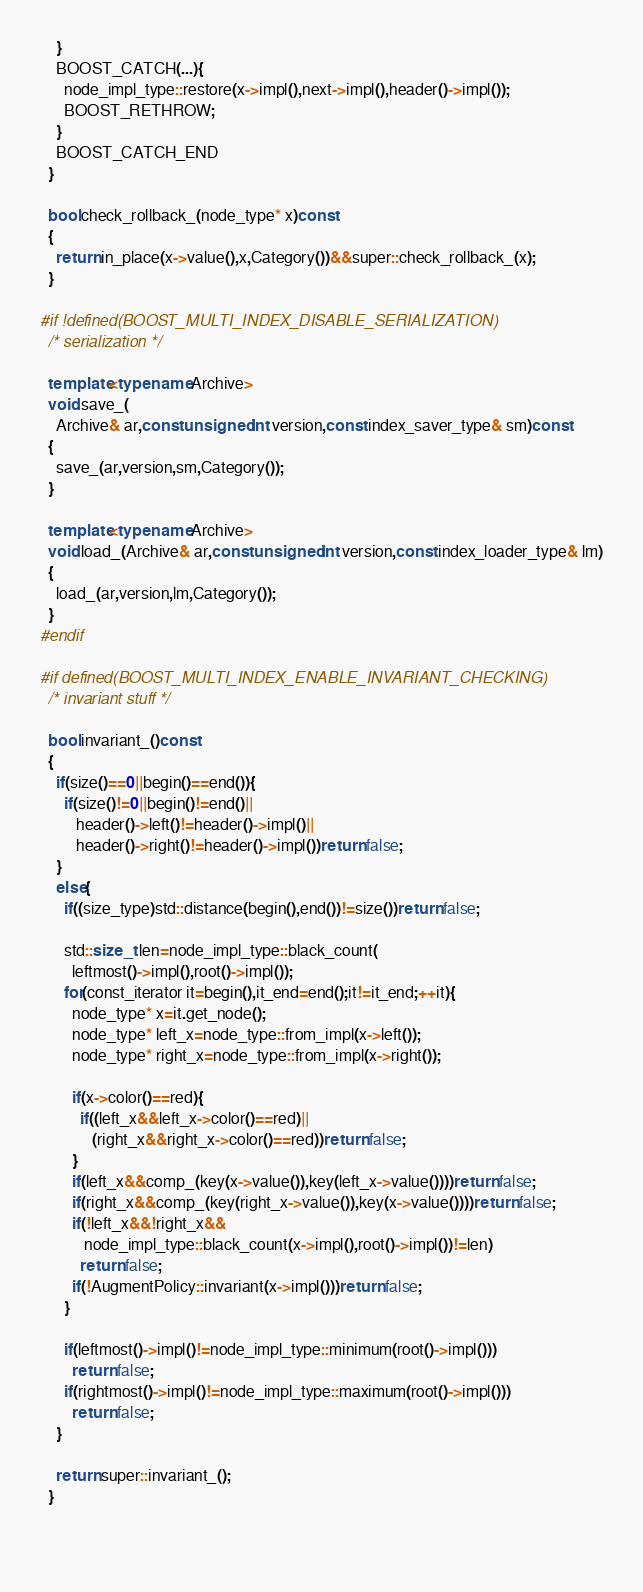<code> <loc_0><loc_0><loc_500><loc_500><_C++_>    }
    BOOST_CATCH(...){
      node_impl_type::restore(x->impl(),next->impl(),header()->impl());
      BOOST_RETHROW;
    }
    BOOST_CATCH_END
  }

  bool check_rollback_(node_type* x)const
  {
    return in_place(x->value(),x,Category())&&super::check_rollback_(x);
  }

#if !defined(BOOST_MULTI_INDEX_DISABLE_SERIALIZATION)
  /* serialization */

  template<typename Archive>
  void save_(
    Archive& ar,const unsigned int version,const index_saver_type& sm)const
  {
    save_(ar,version,sm,Category());
  }

  template<typename Archive>
  void load_(Archive& ar,const unsigned int version,const index_loader_type& lm)
  {
    load_(ar,version,lm,Category());
  }
#endif

#if defined(BOOST_MULTI_INDEX_ENABLE_INVARIANT_CHECKING)
  /* invariant stuff */

  bool invariant_()const
  {
    if(size()==0||begin()==end()){
      if(size()!=0||begin()!=end()||
         header()->left()!=header()->impl()||
         header()->right()!=header()->impl())return false;
    }
    else{
      if((size_type)std::distance(begin(),end())!=size())return false;

      std::size_t len=node_impl_type::black_count(
        leftmost()->impl(),root()->impl());
      for(const_iterator it=begin(),it_end=end();it!=it_end;++it){
        node_type* x=it.get_node();
        node_type* left_x=node_type::from_impl(x->left());
        node_type* right_x=node_type::from_impl(x->right());

        if(x->color()==red){
          if((left_x&&left_x->color()==red)||
             (right_x&&right_x->color()==red))return false;
        }
        if(left_x&&comp_(key(x->value()),key(left_x->value())))return false;
        if(right_x&&comp_(key(right_x->value()),key(x->value())))return false;
        if(!left_x&&!right_x&&
           node_impl_type::black_count(x->impl(),root()->impl())!=len)
          return false;
        if(!AugmentPolicy::invariant(x->impl()))return false;
      }
    
      if(leftmost()->impl()!=node_impl_type::minimum(root()->impl()))
        return false;
      if(rightmost()->impl()!=node_impl_type::maximum(root()->impl()))
        return false;
    }

    return super::invariant_();
  }

  </code> 